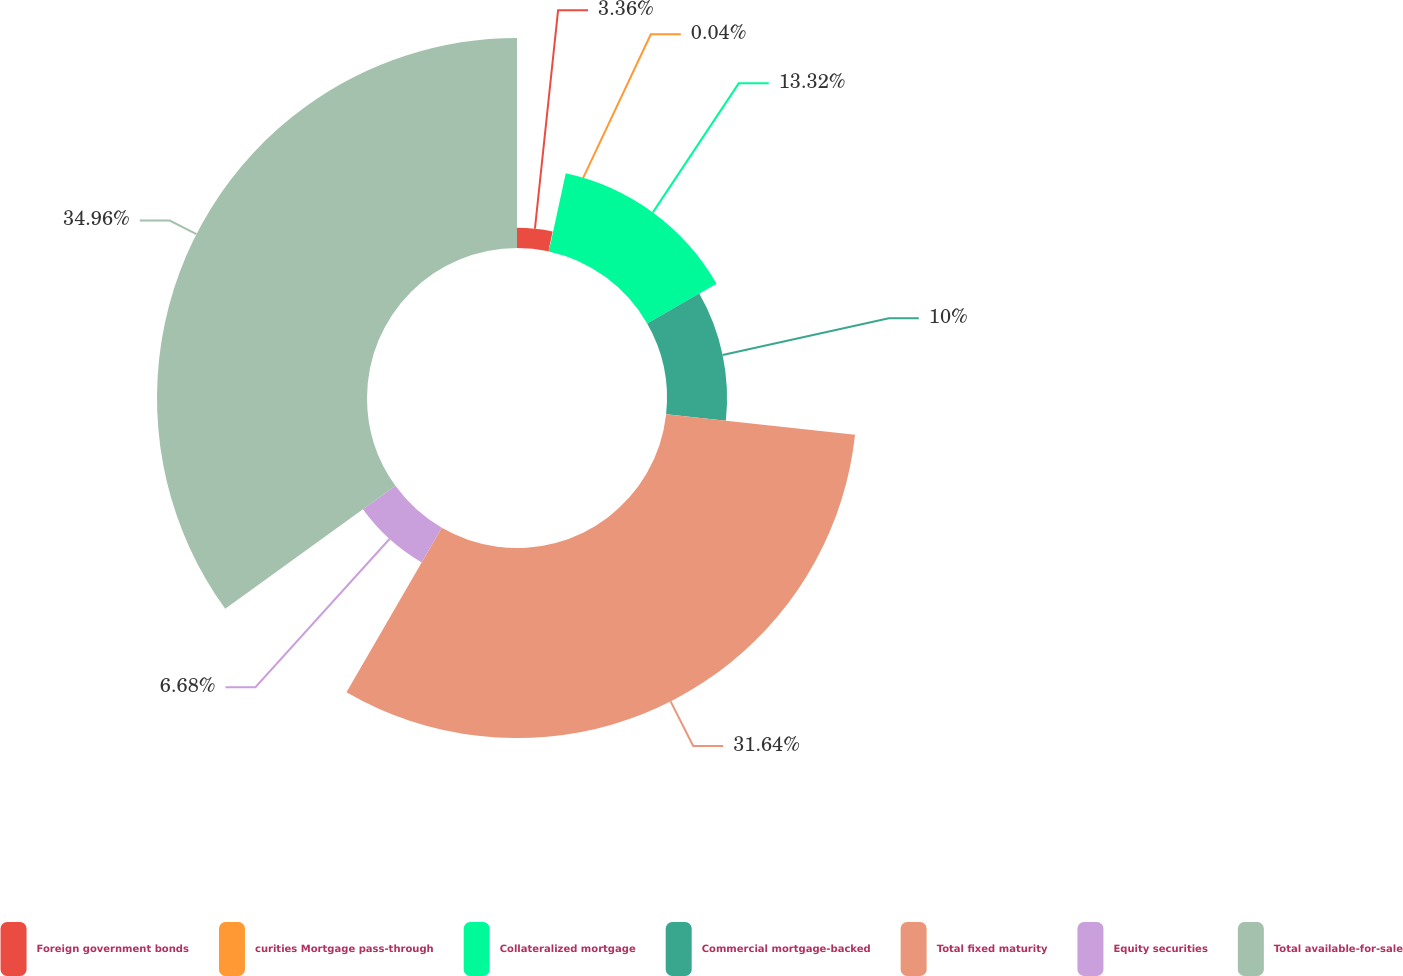Convert chart. <chart><loc_0><loc_0><loc_500><loc_500><pie_chart><fcel>Foreign government bonds<fcel>curities Mortgage pass-through<fcel>Collateralized mortgage<fcel>Commercial mortgage-backed<fcel>Total fixed maturity<fcel>Equity securities<fcel>Total available-for-sale<nl><fcel>3.36%<fcel>0.04%<fcel>13.32%<fcel>10.0%<fcel>31.64%<fcel>6.68%<fcel>34.96%<nl></chart> 